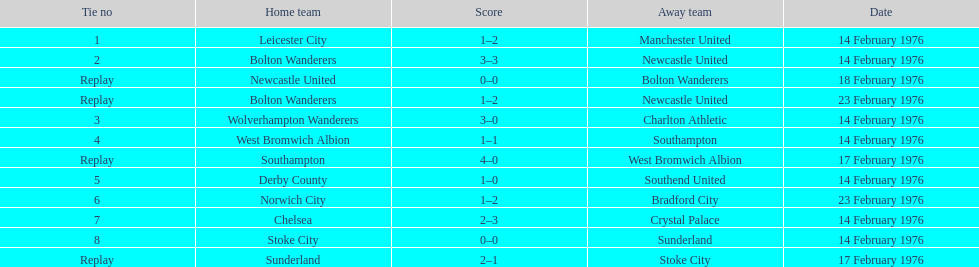How many of these games occurred before 17 february 1976? 7. 